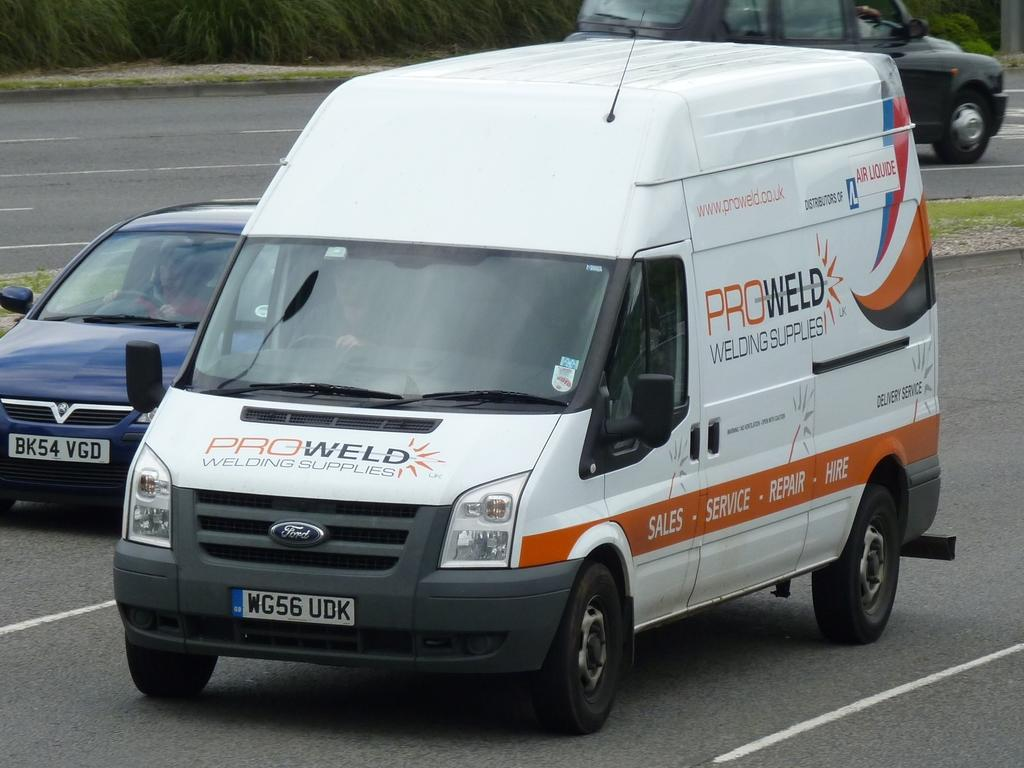<image>
Give a short and clear explanation of the subsequent image. The company van is from the company Proweld 